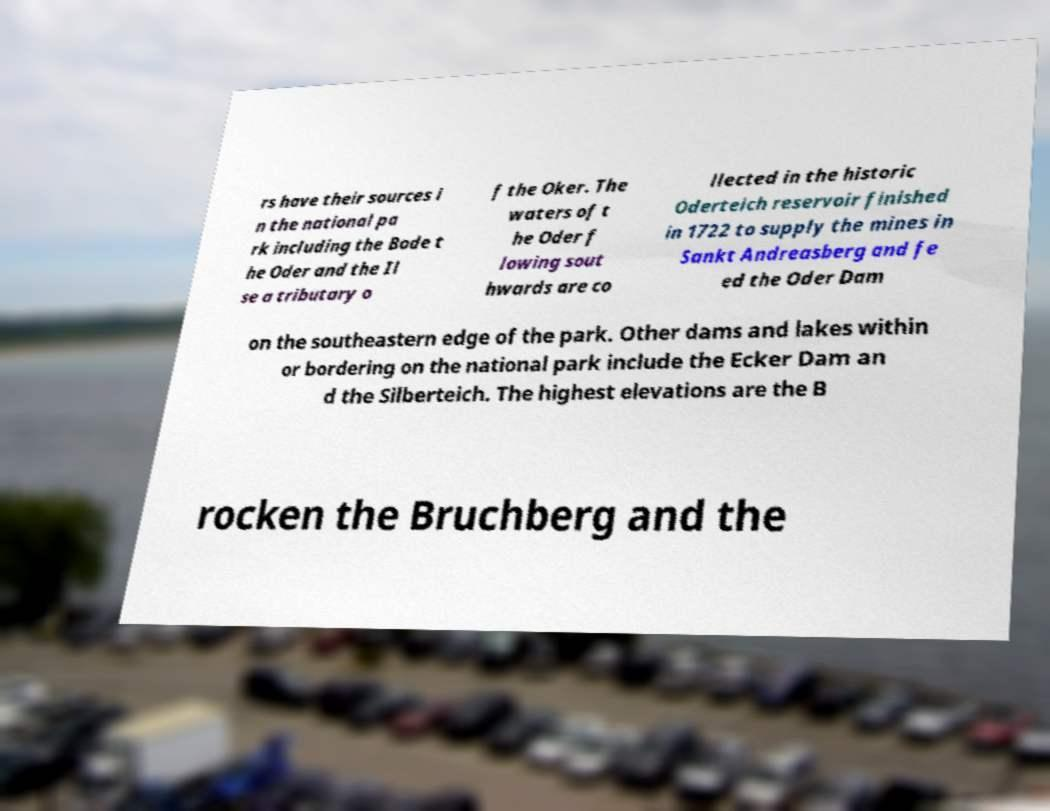I need the written content from this picture converted into text. Can you do that? rs have their sources i n the national pa rk including the Bode t he Oder and the Il se a tributary o f the Oker. The waters of t he Oder f lowing sout hwards are co llected in the historic Oderteich reservoir finished in 1722 to supply the mines in Sankt Andreasberg and fe ed the Oder Dam on the southeastern edge of the park. Other dams and lakes within or bordering on the national park include the Ecker Dam an d the Silberteich. The highest elevations are the B rocken the Bruchberg and the 